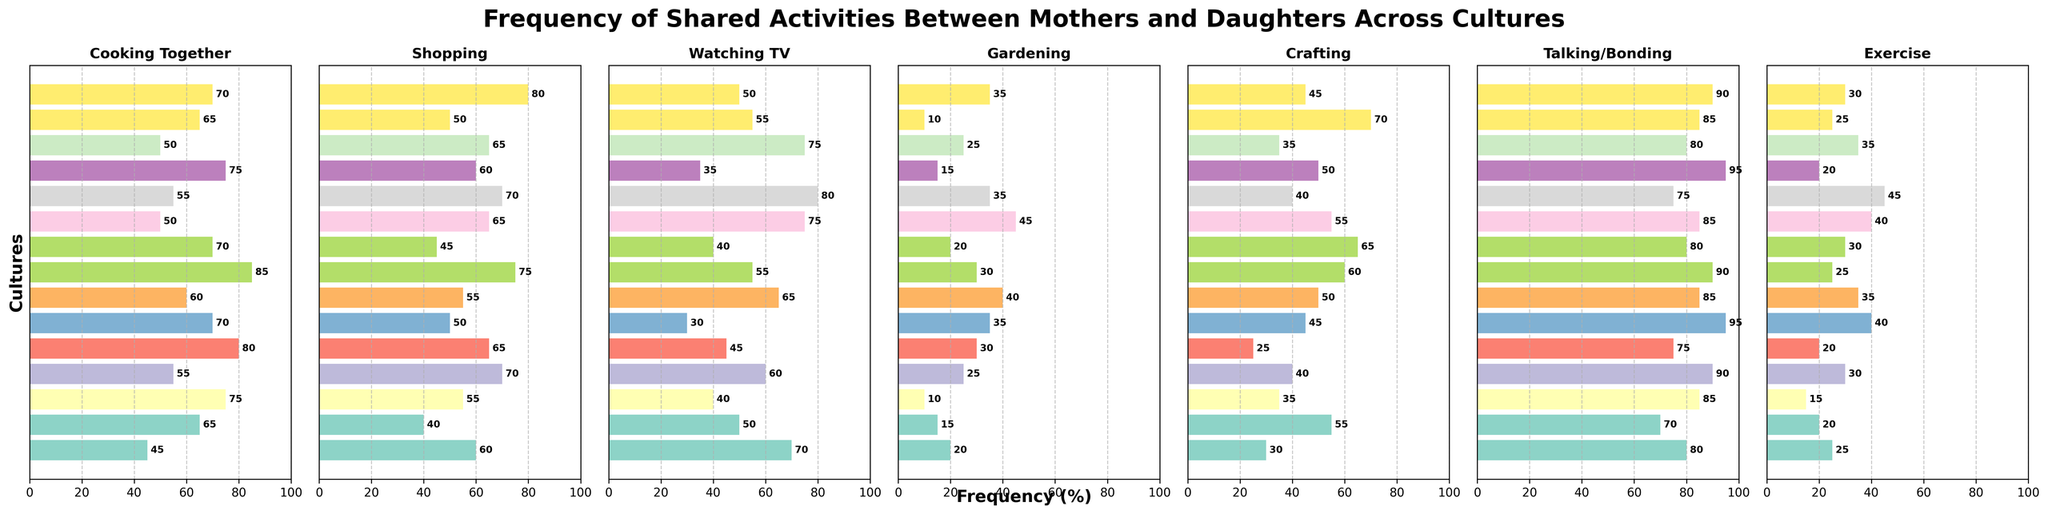What culture has the highest frequency for Cooking Together? The highest bar in the Cooking Together subplot indicates the culture with the highest frequency. For Cooking Together, the Mexican culture has the highest bar at 85%.
Answer: Mexican Which activity has the lowest frequency in South Korean culture? By examining the bars for South Korea across all activities, Gardening has the shortest bar at 10%.
Answer: Gardening Compare Cooking Together between Italian and Canadian cultures. Which one has a higher frequency? By comparing the height of the bars in the Cooking Together subplot, the Italian culture has a taller bar at 80% compared to the Canadian culture at 50%.
Answer: Italian What is the average frequency of Exercise across all cultures? Sum of frequencies for Exercise: 25 + 20 + 15 + 30 + 20 + 40 + 35 + 25 + 30 + 40 + 45 + 20 + 35 + 25 + 30 = 435. There are 15 cultures, so the average is 435/15 = 29%.
Answer: 29% Identify the culture with the most balanced activities (least discrepancy between highest and lowest frequency). Assign each culture's differences between highest and lowest frequencies and compare. Brazilian culture has activities ranging from 25% (Gardening) to 90% (Talking/Bonding), with the smallest range of 65 percentage points compared to others.
Answer: Brazilian Which two cultures have the closest frequency in Watching TV? By examining bars in Watching TV, American (70%) and Canadian (75%) have the closest values as they are 5 percentage points apart.
Answer: American and Canadian How does the frequency of Crafting compare between Japanese and Chinese cultures? Comparing the height of the bars in the Crafting subplot, Chinese have a higher frequency at 65% compared to Japanese at 55%.
Answer: Chinese Calculate the difference in Shopping activity between French and American cultures. The frequency for Shopping is 80% for French and 60% for American, so the difference is 80 - 60 = 20%.
Answer: 20% What is the most prevalent shared activity among all the cultures? By evaluating each subplot, Talking/Bonding has the highest max frequency with Nigerian and Egyptian both at 95%.
Answer: Talking/Bonding 